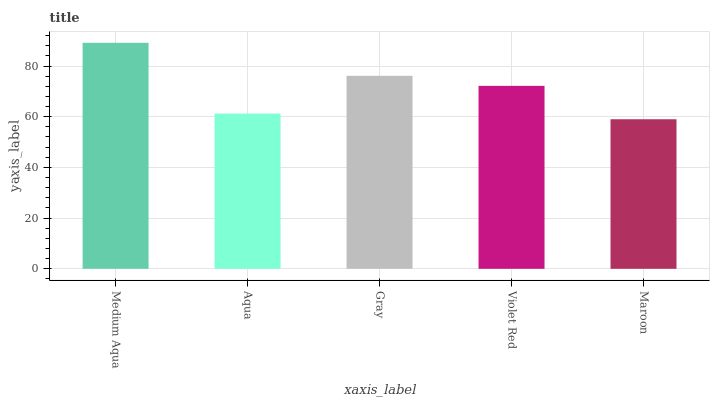Is Maroon the minimum?
Answer yes or no. Yes. Is Medium Aqua the maximum?
Answer yes or no. Yes. Is Aqua the minimum?
Answer yes or no. No. Is Aqua the maximum?
Answer yes or no. No. Is Medium Aqua greater than Aqua?
Answer yes or no. Yes. Is Aqua less than Medium Aqua?
Answer yes or no. Yes. Is Aqua greater than Medium Aqua?
Answer yes or no. No. Is Medium Aqua less than Aqua?
Answer yes or no. No. Is Violet Red the high median?
Answer yes or no. Yes. Is Violet Red the low median?
Answer yes or no. Yes. Is Gray the high median?
Answer yes or no. No. Is Maroon the low median?
Answer yes or no. No. 